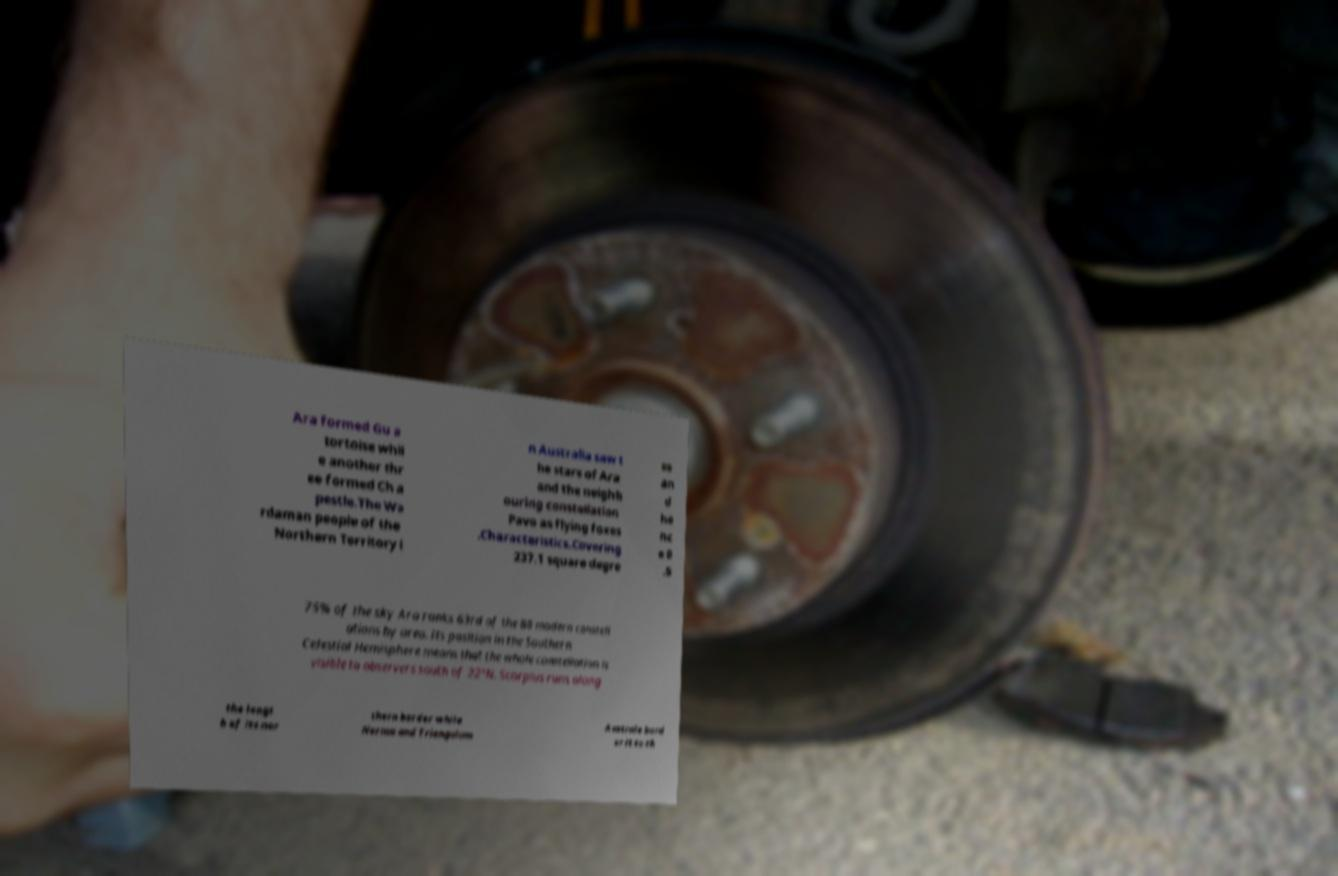For documentation purposes, I need the text within this image transcribed. Could you provide that? Ara formed Gu a tortoise whil e another thr ee formed Ch a pestle.The Wa rdaman people of the Northern Territory i n Australia saw t he stars of Ara and the neighb ouring constellation Pavo as flying foxes .Characteristics.Covering 237.1 square degre es an d he nc e 0 .5 75% of the sky Ara ranks 63rd of the 88 modern constell ations by area. Its position in the Southern Celestial Hemisphere means that the whole constellation is visible to observers south of 22°N. Scorpius runs along the lengt h of its nor thern border while Norma and Triangulum Australe bord er it to th 